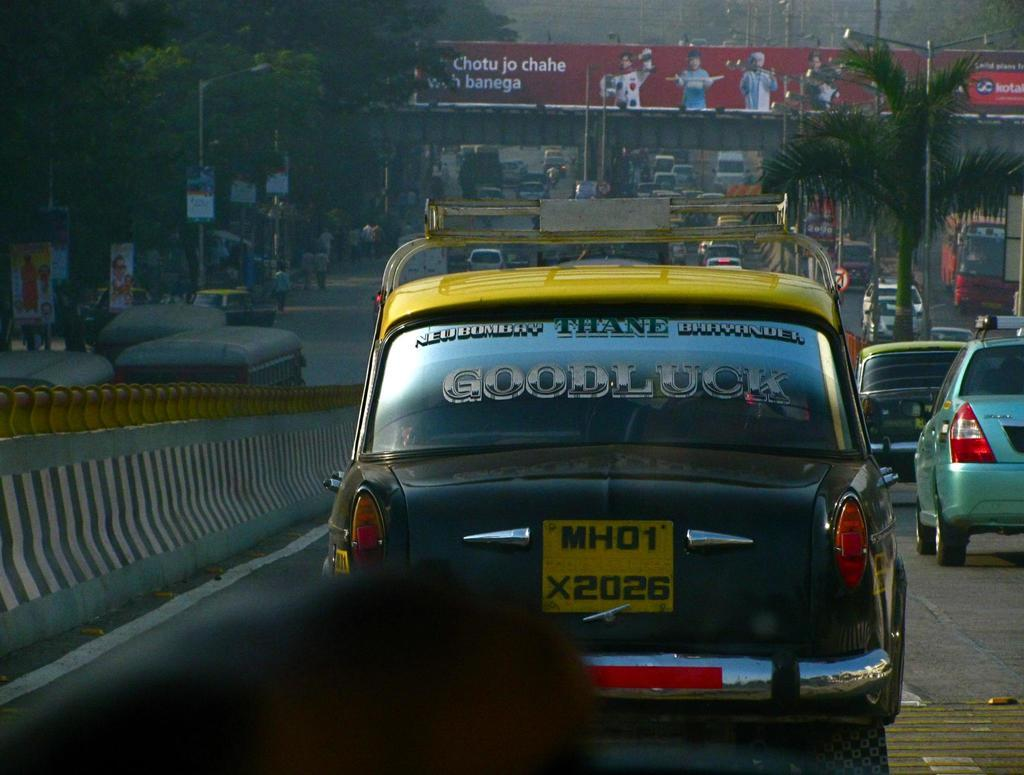Provide a one-sentence caption for the provided image. Cars lined up in traffic, older foreign cars one that says Good luck on the rear window. 